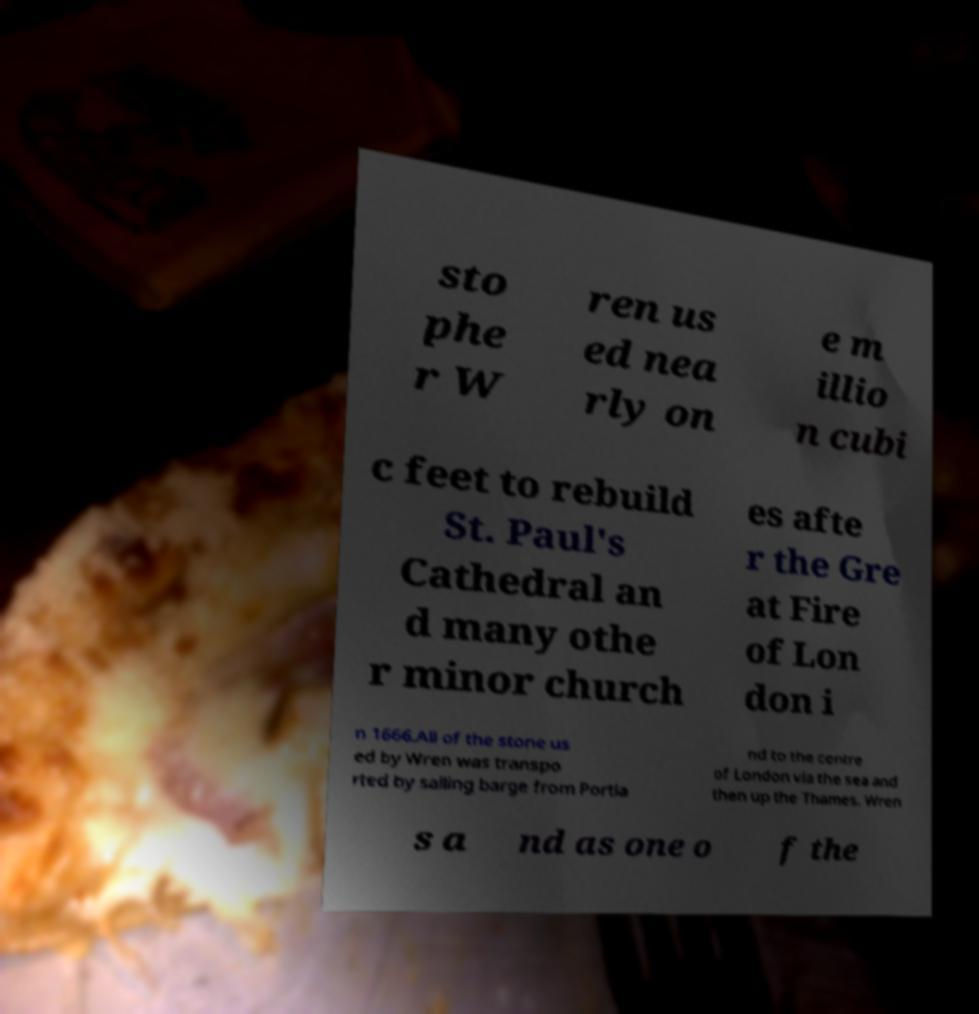Could you extract and type out the text from this image? sto phe r W ren us ed nea rly on e m illio n cubi c feet to rebuild St. Paul's Cathedral an d many othe r minor church es afte r the Gre at Fire of Lon don i n 1666.All of the stone us ed by Wren was transpo rted by sailing barge from Portla nd to the centre of London via the sea and then up the Thames. Wren s a nd as one o f the 